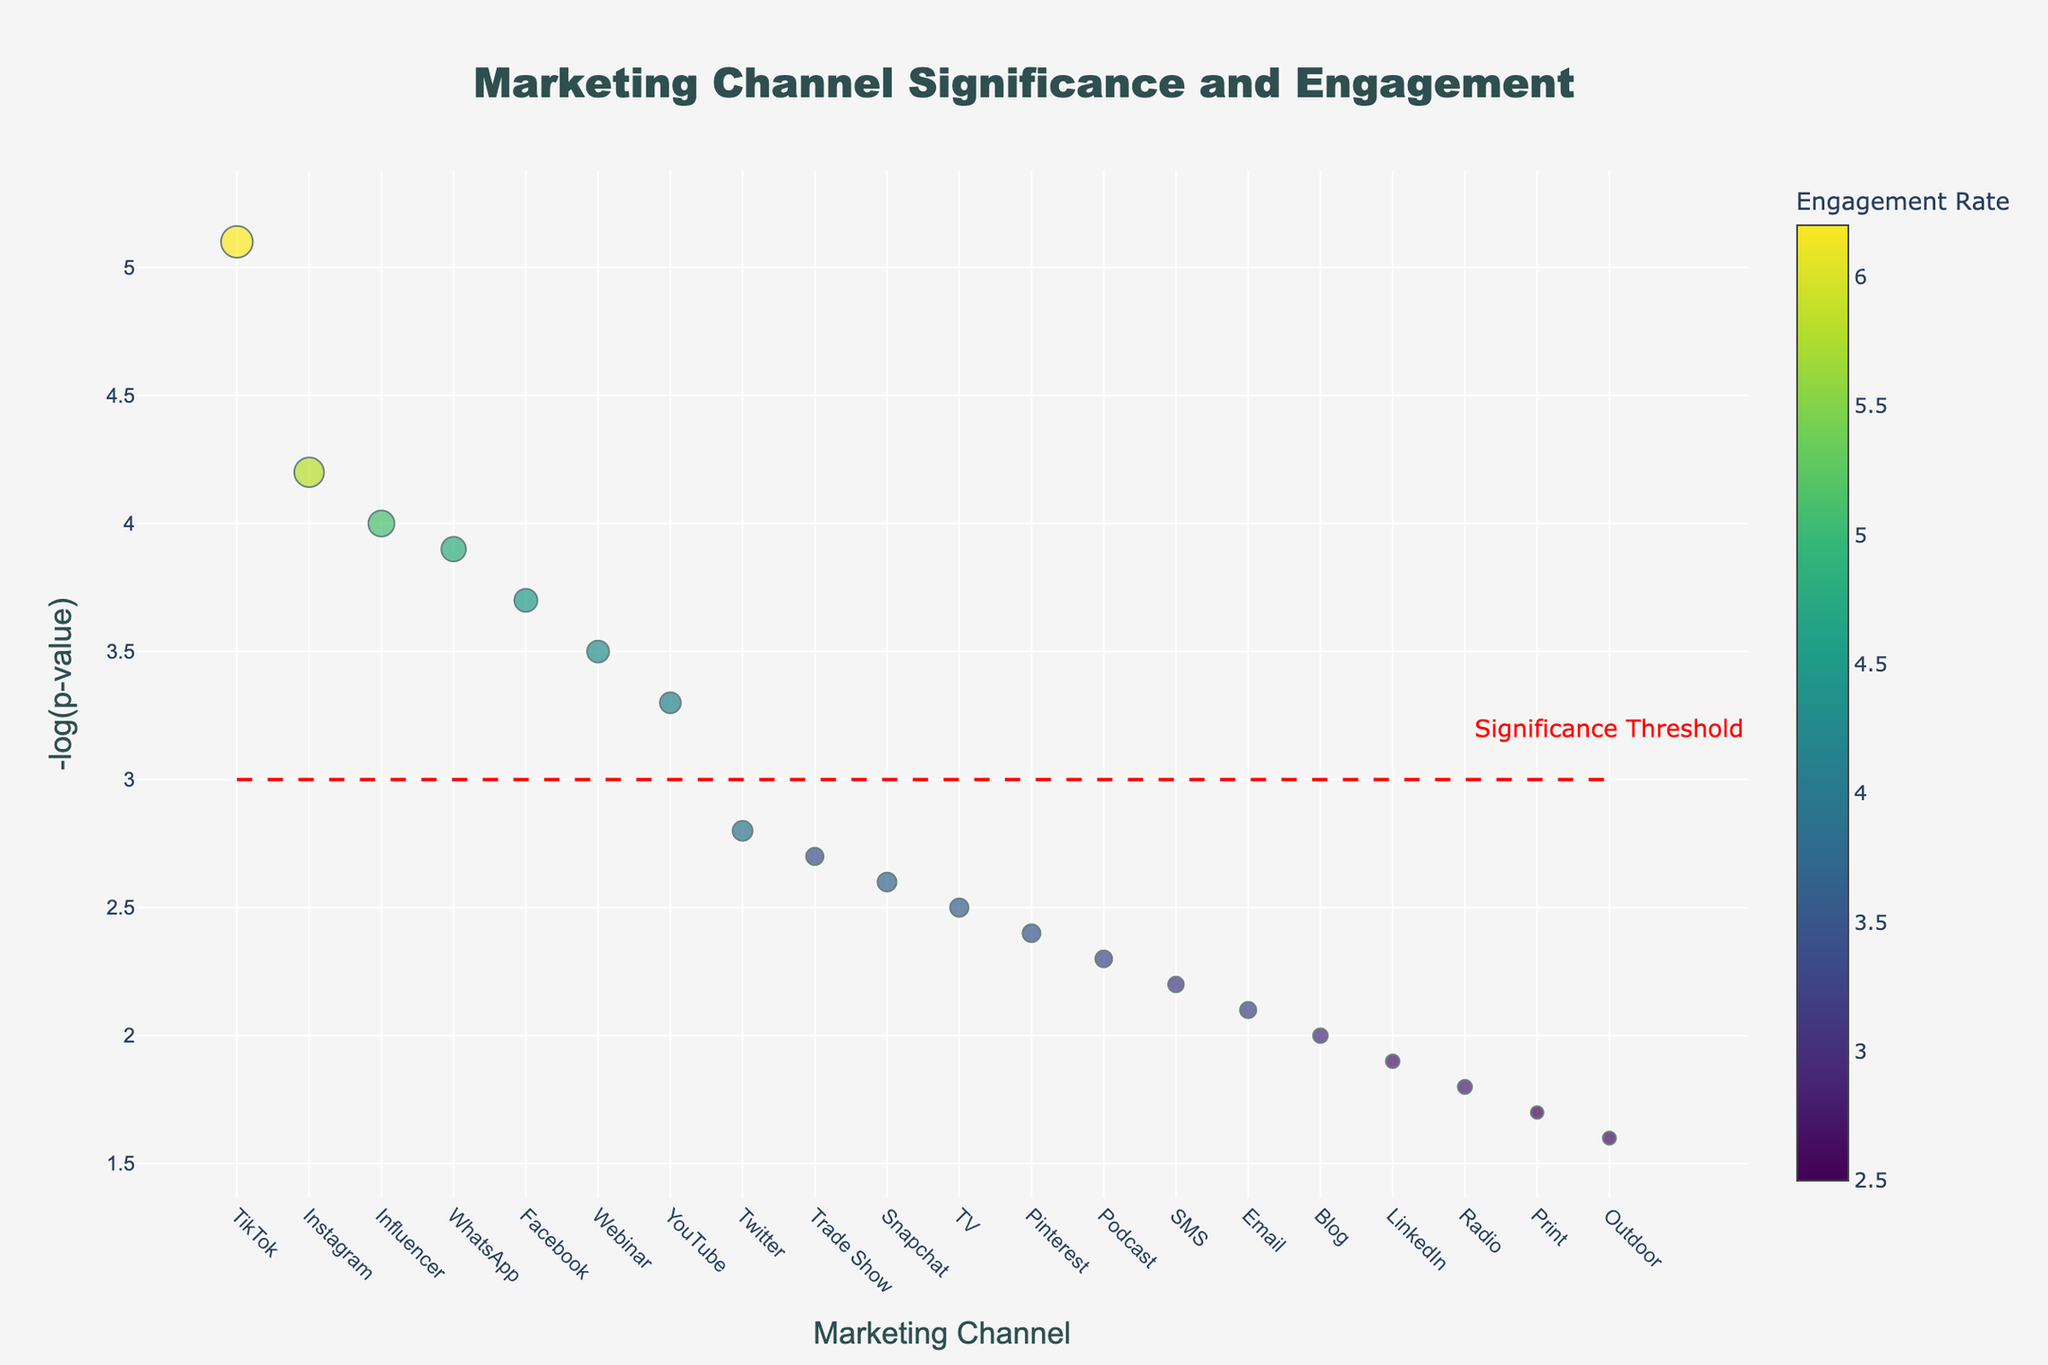What is the title of the plot? The title is usually placed at the top center of the plot. In this figure, it reads "Marketing Channel Significance and Engagement".
Answer: Marketing Channel Significance and Engagement What does the y-axis represent? The y-axis label can be found on the left side of the plot. It reads "-log(p-value)", indicating that this axis represents the negative logarithm of the p-values.
Answer: -log(p-value) Which marketing channel has the highest engagement rate? Identify the marker associated with the highest value on the color scale, which represents engagement rate. TikTok has the highest value with an engagement rate of 6.2.
Answer: TikTok How many marketing channels have a negative log p-value greater than the significance threshold of 3? Look for markers that are above the red dashed line at y=3. Channels with markers above this line are Facebook, Instagram, WhatsApp, TikTok, Webinar, and Influencer, totaling 6 channels.
Answer: 6 Which channels have engagement rates below 3.0? Identify the markers with smaller sizes that correspond to engagement rates. Channels LinkedIn, Blog, Print, Radio, and Outdoor all have engagement rates below 3.0.
Answer: LinkedIn, Blog, Print, Radio, Outdoor What is the significance threshold indicated with the horizontal line? The red dashed line represents the significance threshold set at -log(p-value) = 3. This is also annotated as "Significance Threshold" on the plot.
Answer: 3 Which channels have both high engagement rates and high significance (negative log p-value)? Look for markers that are both large and situated above the red dashed line. Channels including Instagram, TikTok, WhatsApp, and Influencer meet this criterion.
Answer: Instagram, TikTok, WhatsApp, Influencer Which channel has the lowest negative log p-value and how does it compare to the significance threshold? Look for the channel with the smallest y-value. Outdoor has the lowest negative log p-value of 1.6, which is below the significance threshold of 3.
Answer: Outdoor, below Rank the channels with the highest significance levels (negative log p-values) Organize the channels by their negative log p-values in descending order. The top channels are TikTok, Instagram, WhatsApp, Influencer, Facebook, and Webinar.
Answer: TikTok, Instagram, WhatsApp, Influencer, Facebook, Webinar 